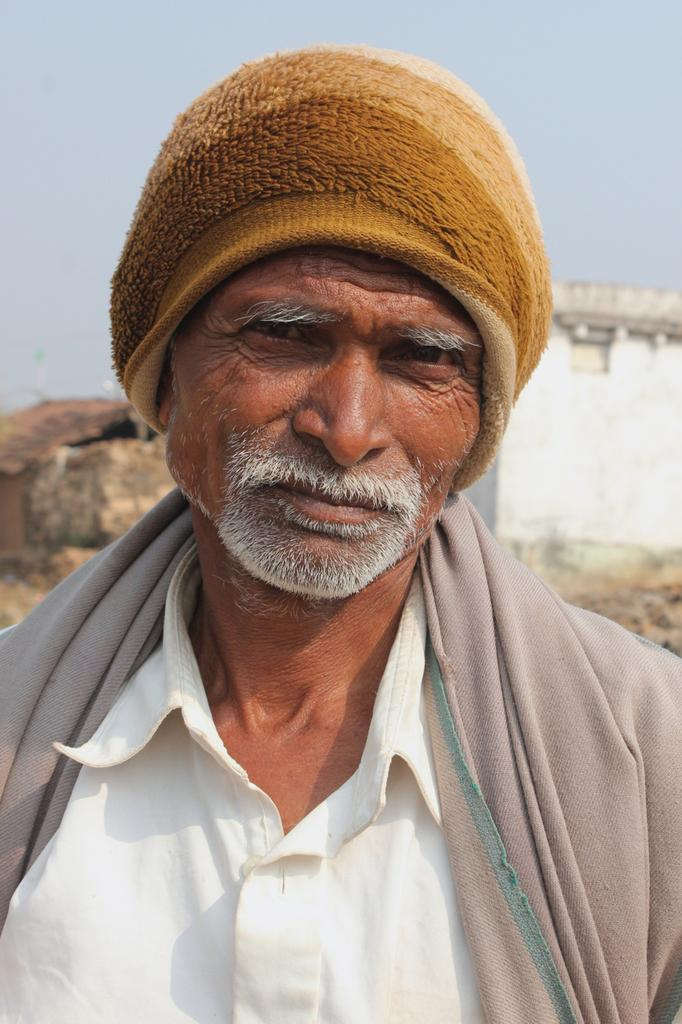Who or what is the main subject in the image? There is a person in the image. What is the person wearing on their head? The person is wearing a woolen cap. Can you describe the background of the image? There may be a house behind the person, and the sky is visible in the image. Where is the lunchroom located in the image? There is no lunchroom present in the image. Can you tell me how the person stops in the image? The image does not show the person stopping or any indication of movement, so it cannot be determined from the image. 